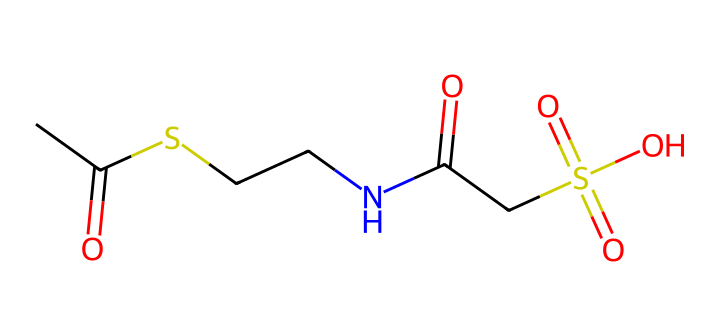What is the total number of sulfur atoms in the compound? By examining the SMILES representation, we can see the presence of "S" three times, indicating that there are three sulfur atoms in the compound.
Answer: three How many carbon atoms are present in this structure? In the provided SMILES, "C" appears five times, which corresponds to the five carbon atoms in the structure.
Answer: five What functional group is indicated by “=O” in the SMILES? The presence of “=O” indicates carbonyl groups (C=O), which are characteristic of both ketones and aldehydes. In this compound, there are two carbonyl groups.
Answer: carbonyl What type of bonding is indicated by the “N” atom in the structure? The presence of the nitrogen atom ("N") suggests that the compound contains an amine functional group, indicating the possible presence of amine-type bonding.
Answer: amine Does this compound contain any acidic functional groups? The presence of “S(=O)(=O)O” indicates a sulfonic acid functional group, which is acidic in nature because of the -SO3H structure.
Answer: yes What is the molecular geometry expected around sulfur atoms in this compound? Sulfur typically exhibits a tetrahedral or trigonal bipyramidal molecular geometry due to its ability to expand its valence shell and accommodate more than four bonds, especially in the presence of multiple electronegative atoms like oxygen.
Answer: tetrahedral or trigonal bipyramidal How does the presence of sulfur influence the properties of this compound? Sulfur typically introduces unique properties like increased solubility and reactivity due to its electronegativity and ability to form various oxidation states, which can enhance the effectiveness of fixatives in preserving art.
Answer: increased reactivity 